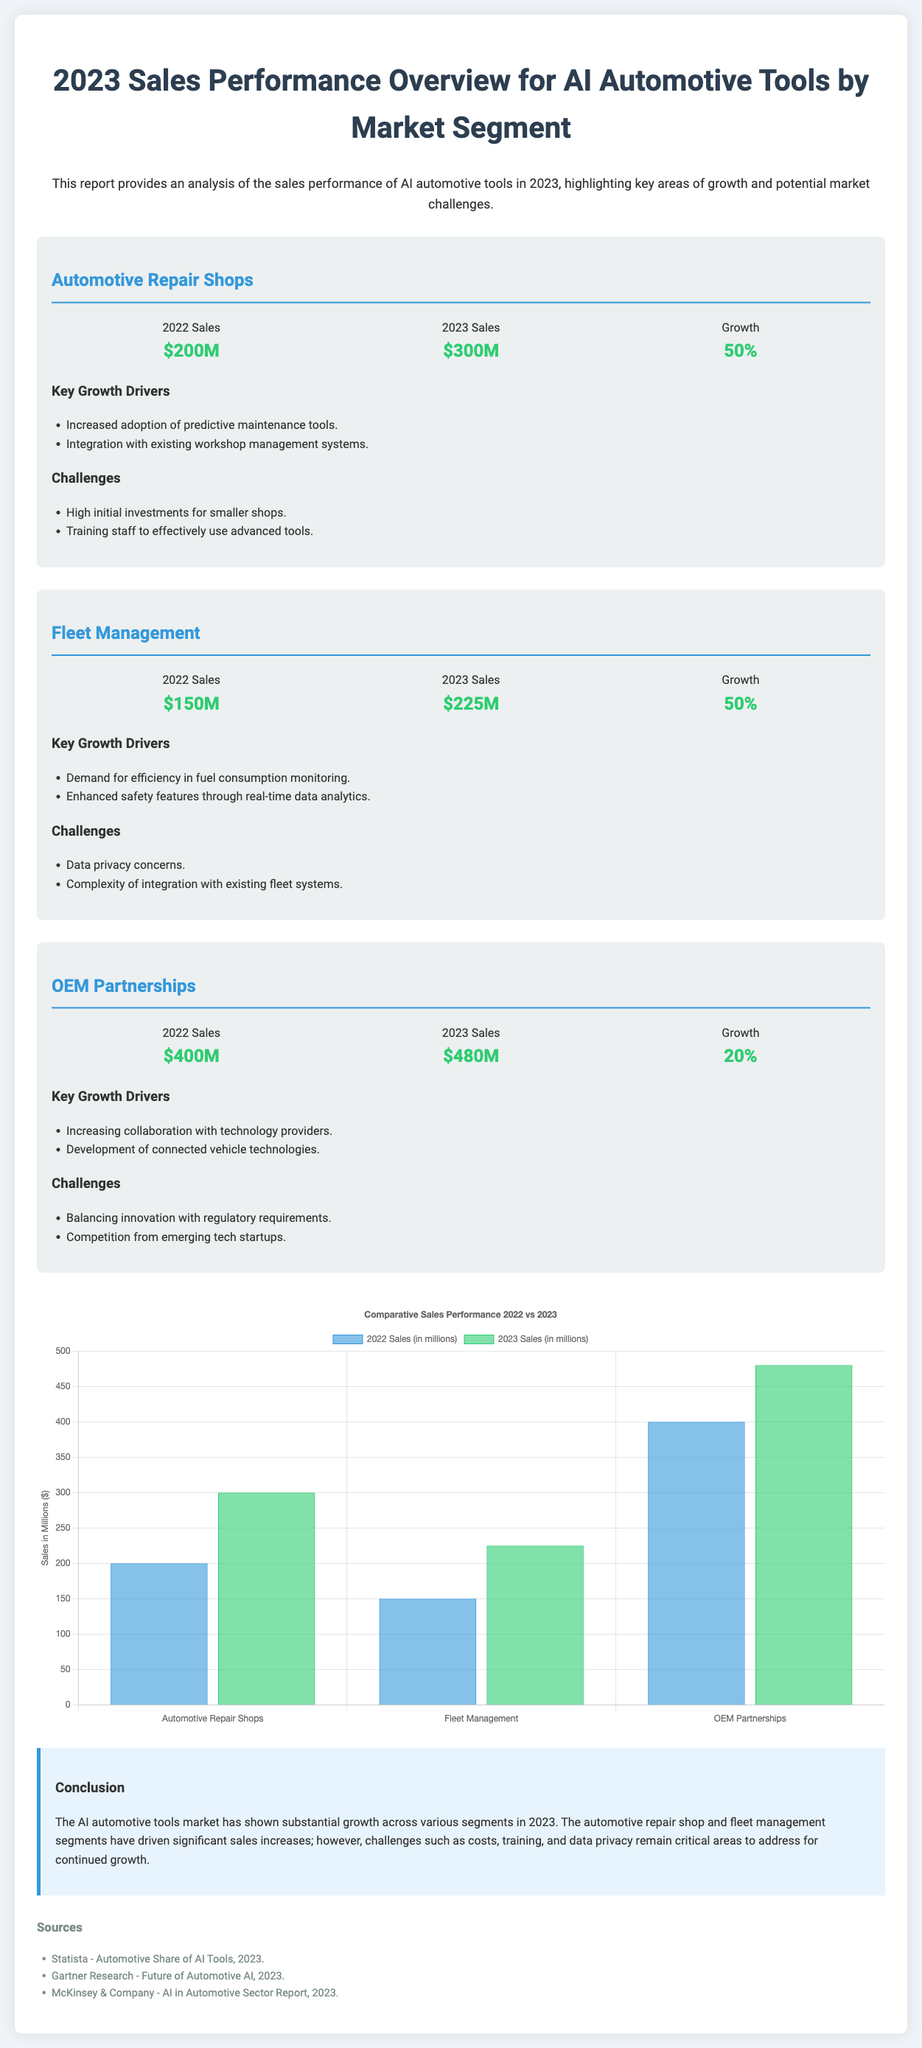what were the 2022 sales for Automotive Repair Shops? The 2022 sales for Automotive Repair Shops can be found in the performance section of the document, which states $200M.
Answer: $200M what is the growth percentage for Fleet Management in 2023? The growth percentage for Fleet Management is provided in the performance section that shows a 50% increase from 2022 to 2023.
Answer: 50% what were the 2023 sales for OEM Partnerships? The 2023 sales for OEM Partnerships is indicated in the performance section, amounting to $480M.
Answer: $480M name one key growth driver for Automotive Repair Shops. The document lists several key growth drivers, one of which is increased adoption of predictive maintenance tools.
Answer: increased adoption of predictive maintenance tools what challenge is mentioned for Fleet Management regarding data? The document lists a challenge for Fleet Management as data privacy concerns.
Answer: data privacy concerns how much did Automotive Repair Shops increase in sales from 2022 to 2023? The increase in sales from 2022 to 2023 for Automotive Repair Shops is calculated as $300M - $200M, resulting in a $100M increase.
Answer: $100M what does the chart in the document compare? The chart compares the sales figures for Automotive Repair Shops, Fleet Management, and OEM Partnerships from 2022 to 2023.
Answer: sales figures from 2022 to 2023 which segment had the highest sales in 2022? The document states that OEM Partnerships had the highest sales in 2022 at $400M.
Answer: OEM Partnerships what is the title of the document? The title of the document is explicitly mentioned at the top of the report: "2023 Sales Performance Overview for AI Automotive Tools by Market Segment".
Answer: 2023 Sales Performance Overview for AI Automotive Tools by Market Segment 